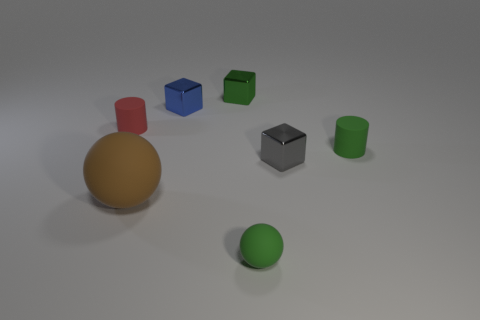Add 1 brown metal cylinders. How many objects exist? 8 Subtract all cubes. How many objects are left? 4 Subtract all red rubber things. Subtract all rubber spheres. How many objects are left? 4 Add 1 cylinders. How many cylinders are left? 3 Add 3 large green shiny objects. How many large green shiny objects exist? 3 Subtract 0 brown blocks. How many objects are left? 7 